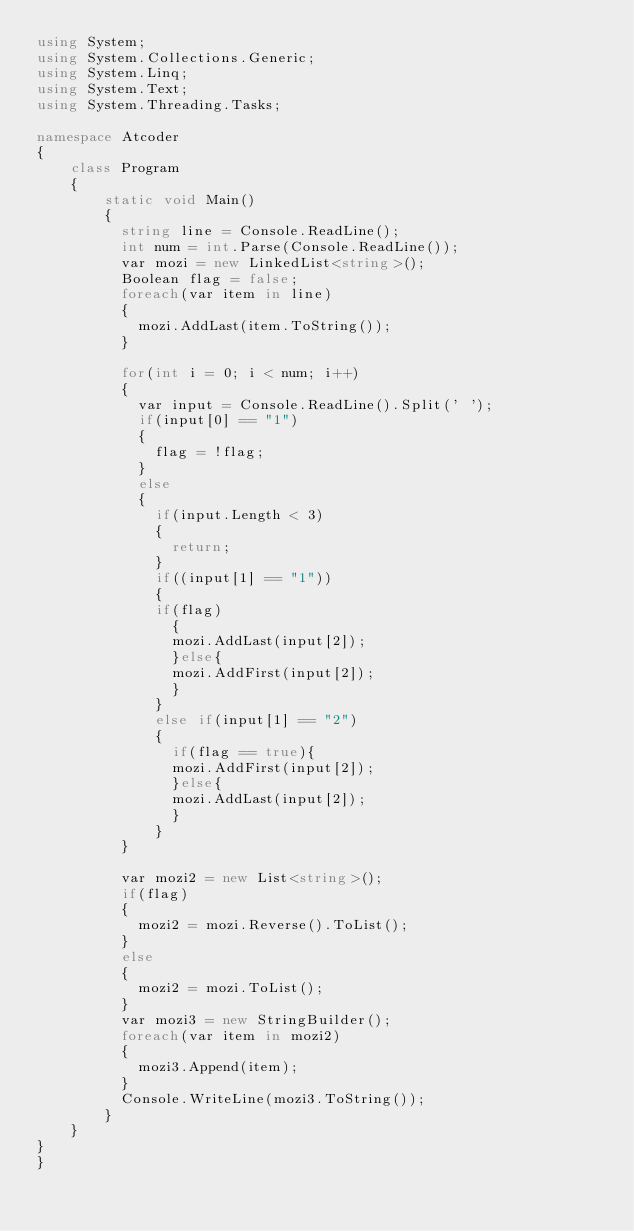Convert code to text. <code><loc_0><loc_0><loc_500><loc_500><_C#_>using System;
using System.Collections.Generic;
using System.Linq;
using System.Text;
using System.Threading.Tasks;
 
namespace Atcoder
{
    class Program
    { 
        static void Main()
        {          
          string line = Console.ReadLine();
          int num = int.Parse(Console.ReadLine());
          var mozi = new LinkedList<string>();
          Boolean flag = false;
          foreach(var item in line)
          {
            mozi.AddLast(item.ToString());
          }
          
          for(int i = 0; i < num; i++)
          {
          	var input = Console.ReadLine().Split(' ');
            if(input[0] == "1")
            {
              flag = !flag;
            }
            else 
            {
              if(input.Length < 3)
              {
                return;
              }
              if((input[1] == "1"))
              {
              if(flag)
                {
                mozi.AddLast(input[2]);
                }else{
                mozi.AddFirst(input[2]);
                }
              }
              else if(input[1] == "2")
              {
                if(flag == true){
                mozi.AddFirst(input[2]);
                }else{
                mozi.AddLast(input[2]);
                }
              }
          }
          
          var mozi2 = new List<string>();
          if(flag)
          {
            mozi2 = mozi.Reverse().ToList();
          }
          else
          {
            mozi2 = mozi.ToList();
          }
          var mozi3 = new StringBuilder();
          foreach(var item in mozi2)
          {
            mozi3.Append(item);
          }
          Console.WriteLine(mozi3.ToString());
        }
    }
}
}
</code> 